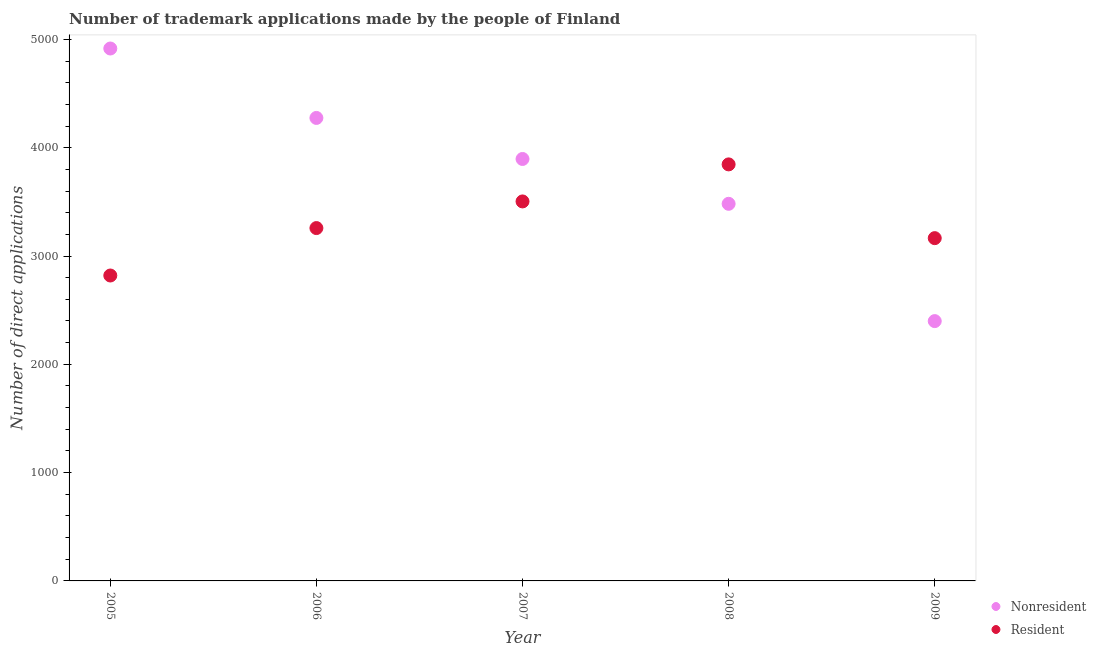Is the number of dotlines equal to the number of legend labels?
Your response must be concise. Yes. What is the number of trademark applications made by residents in 2005?
Ensure brevity in your answer.  2820. Across all years, what is the maximum number of trademark applications made by non residents?
Your answer should be very brief. 4916. Across all years, what is the minimum number of trademark applications made by residents?
Make the answer very short. 2820. What is the total number of trademark applications made by non residents in the graph?
Make the answer very short. 1.90e+04. What is the difference between the number of trademark applications made by non residents in 2005 and that in 2009?
Provide a succinct answer. 2517. What is the difference between the number of trademark applications made by non residents in 2007 and the number of trademark applications made by residents in 2006?
Keep it short and to the point. 638. What is the average number of trademark applications made by residents per year?
Make the answer very short. 3318.6. In the year 2007, what is the difference between the number of trademark applications made by non residents and number of trademark applications made by residents?
Provide a short and direct response. 392. What is the ratio of the number of trademark applications made by residents in 2005 to that in 2006?
Offer a very short reply. 0.87. Is the number of trademark applications made by non residents in 2006 less than that in 2008?
Provide a short and direct response. No. Is the difference between the number of trademark applications made by residents in 2005 and 2006 greater than the difference between the number of trademark applications made by non residents in 2005 and 2006?
Give a very brief answer. No. What is the difference between the highest and the second highest number of trademark applications made by non residents?
Your response must be concise. 641. What is the difference between the highest and the lowest number of trademark applications made by non residents?
Provide a succinct answer. 2517. In how many years, is the number of trademark applications made by residents greater than the average number of trademark applications made by residents taken over all years?
Your answer should be compact. 2. Is the sum of the number of trademark applications made by non residents in 2008 and 2009 greater than the maximum number of trademark applications made by residents across all years?
Your answer should be compact. Yes. Does the number of trademark applications made by residents monotonically increase over the years?
Provide a short and direct response. No. Is the number of trademark applications made by residents strictly greater than the number of trademark applications made by non residents over the years?
Offer a very short reply. No. How many years are there in the graph?
Your answer should be very brief. 5. Are the values on the major ticks of Y-axis written in scientific E-notation?
Your response must be concise. No. Does the graph contain grids?
Ensure brevity in your answer.  No. Where does the legend appear in the graph?
Make the answer very short. Bottom right. How many legend labels are there?
Keep it short and to the point. 2. What is the title of the graph?
Your response must be concise. Number of trademark applications made by the people of Finland. Does "Urban" appear as one of the legend labels in the graph?
Your response must be concise. No. What is the label or title of the Y-axis?
Your answer should be compact. Number of direct applications. What is the Number of direct applications in Nonresident in 2005?
Offer a terse response. 4916. What is the Number of direct applications in Resident in 2005?
Offer a terse response. 2820. What is the Number of direct applications in Nonresident in 2006?
Provide a short and direct response. 4275. What is the Number of direct applications in Resident in 2006?
Give a very brief answer. 3258. What is the Number of direct applications of Nonresident in 2007?
Provide a succinct answer. 3896. What is the Number of direct applications of Resident in 2007?
Make the answer very short. 3504. What is the Number of direct applications in Nonresident in 2008?
Offer a terse response. 3482. What is the Number of direct applications of Resident in 2008?
Ensure brevity in your answer.  3846. What is the Number of direct applications in Nonresident in 2009?
Ensure brevity in your answer.  2399. What is the Number of direct applications of Resident in 2009?
Your answer should be compact. 3165. Across all years, what is the maximum Number of direct applications of Nonresident?
Offer a very short reply. 4916. Across all years, what is the maximum Number of direct applications of Resident?
Ensure brevity in your answer.  3846. Across all years, what is the minimum Number of direct applications of Nonresident?
Ensure brevity in your answer.  2399. Across all years, what is the minimum Number of direct applications in Resident?
Your answer should be compact. 2820. What is the total Number of direct applications of Nonresident in the graph?
Keep it short and to the point. 1.90e+04. What is the total Number of direct applications of Resident in the graph?
Your answer should be compact. 1.66e+04. What is the difference between the Number of direct applications in Nonresident in 2005 and that in 2006?
Provide a succinct answer. 641. What is the difference between the Number of direct applications in Resident in 2005 and that in 2006?
Your answer should be very brief. -438. What is the difference between the Number of direct applications of Nonresident in 2005 and that in 2007?
Provide a succinct answer. 1020. What is the difference between the Number of direct applications in Resident in 2005 and that in 2007?
Your answer should be compact. -684. What is the difference between the Number of direct applications of Nonresident in 2005 and that in 2008?
Your answer should be very brief. 1434. What is the difference between the Number of direct applications of Resident in 2005 and that in 2008?
Provide a succinct answer. -1026. What is the difference between the Number of direct applications in Nonresident in 2005 and that in 2009?
Your response must be concise. 2517. What is the difference between the Number of direct applications of Resident in 2005 and that in 2009?
Keep it short and to the point. -345. What is the difference between the Number of direct applications of Nonresident in 2006 and that in 2007?
Your answer should be very brief. 379. What is the difference between the Number of direct applications in Resident in 2006 and that in 2007?
Offer a very short reply. -246. What is the difference between the Number of direct applications in Nonresident in 2006 and that in 2008?
Keep it short and to the point. 793. What is the difference between the Number of direct applications of Resident in 2006 and that in 2008?
Provide a succinct answer. -588. What is the difference between the Number of direct applications of Nonresident in 2006 and that in 2009?
Keep it short and to the point. 1876. What is the difference between the Number of direct applications of Resident in 2006 and that in 2009?
Keep it short and to the point. 93. What is the difference between the Number of direct applications in Nonresident in 2007 and that in 2008?
Offer a very short reply. 414. What is the difference between the Number of direct applications in Resident in 2007 and that in 2008?
Your response must be concise. -342. What is the difference between the Number of direct applications of Nonresident in 2007 and that in 2009?
Provide a short and direct response. 1497. What is the difference between the Number of direct applications of Resident in 2007 and that in 2009?
Your response must be concise. 339. What is the difference between the Number of direct applications in Nonresident in 2008 and that in 2009?
Your answer should be very brief. 1083. What is the difference between the Number of direct applications in Resident in 2008 and that in 2009?
Offer a very short reply. 681. What is the difference between the Number of direct applications of Nonresident in 2005 and the Number of direct applications of Resident in 2006?
Your answer should be compact. 1658. What is the difference between the Number of direct applications in Nonresident in 2005 and the Number of direct applications in Resident in 2007?
Your response must be concise. 1412. What is the difference between the Number of direct applications of Nonresident in 2005 and the Number of direct applications of Resident in 2008?
Keep it short and to the point. 1070. What is the difference between the Number of direct applications of Nonresident in 2005 and the Number of direct applications of Resident in 2009?
Give a very brief answer. 1751. What is the difference between the Number of direct applications of Nonresident in 2006 and the Number of direct applications of Resident in 2007?
Keep it short and to the point. 771. What is the difference between the Number of direct applications of Nonresident in 2006 and the Number of direct applications of Resident in 2008?
Ensure brevity in your answer.  429. What is the difference between the Number of direct applications in Nonresident in 2006 and the Number of direct applications in Resident in 2009?
Offer a very short reply. 1110. What is the difference between the Number of direct applications of Nonresident in 2007 and the Number of direct applications of Resident in 2009?
Give a very brief answer. 731. What is the difference between the Number of direct applications of Nonresident in 2008 and the Number of direct applications of Resident in 2009?
Your answer should be very brief. 317. What is the average Number of direct applications of Nonresident per year?
Offer a very short reply. 3793.6. What is the average Number of direct applications in Resident per year?
Provide a short and direct response. 3318.6. In the year 2005, what is the difference between the Number of direct applications in Nonresident and Number of direct applications in Resident?
Offer a terse response. 2096. In the year 2006, what is the difference between the Number of direct applications in Nonresident and Number of direct applications in Resident?
Keep it short and to the point. 1017. In the year 2007, what is the difference between the Number of direct applications of Nonresident and Number of direct applications of Resident?
Your response must be concise. 392. In the year 2008, what is the difference between the Number of direct applications of Nonresident and Number of direct applications of Resident?
Ensure brevity in your answer.  -364. In the year 2009, what is the difference between the Number of direct applications of Nonresident and Number of direct applications of Resident?
Provide a short and direct response. -766. What is the ratio of the Number of direct applications in Nonresident in 2005 to that in 2006?
Your answer should be very brief. 1.15. What is the ratio of the Number of direct applications in Resident in 2005 to that in 2006?
Provide a short and direct response. 0.87. What is the ratio of the Number of direct applications in Nonresident in 2005 to that in 2007?
Keep it short and to the point. 1.26. What is the ratio of the Number of direct applications in Resident in 2005 to that in 2007?
Offer a very short reply. 0.8. What is the ratio of the Number of direct applications in Nonresident in 2005 to that in 2008?
Provide a short and direct response. 1.41. What is the ratio of the Number of direct applications in Resident in 2005 to that in 2008?
Give a very brief answer. 0.73. What is the ratio of the Number of direct applications in Nonresident in 2005 to that in 2009?
Your answer should be compact. 2.05. What is the ratio of the Number of direct applications in Resident in 2005 to that in 2009?
Keep it short and to the point. 0.89. What is the ratio of the Number of direct applications in Nonresident in 2006 to that in 2007?
Your answer should be compact. 1.1. What is the ratio of the Number of direct applications in Resident in 2006 to that in 2007?
Your answer should be compact. 0.93. What is the ratio of the Number of direct applications in Nonresident in 2006 to that in 2008?
Make the answer very short. 1.23. What is the ratio of the Number of direct applications of Resident in 2006 to that in 2008?
Your answer should be compact. 0.85. What is the ratio of the Number of direct applications of Nonresident in 2006 to that in 2009?
Your answer should be compact. 1.78. What is the ratio of the Number of direct applications of Resident in 2006 to that in 2009?
Offer a terse response. 1.03. What is the ratio of the Number of direct applications of Nonresident in 2007 to that in 2008?
Provide a succinct answer. 1.12. What is the ratio of the Number of direct applications of Resident in 2007 to that in 2008?
Your answer should be very brief. 0.91. What is the ratio of the Number of direct applications in Nonresident in 2007 to that in 2009?
Ensure brevity in your answer.  1.62. What is the ratio of the Number of direct applications of Resident in 2007 to that in 2009?
Offer a very short reply. 1.11. What is the ratio of the Number of direct applications of Nonresident in 2008 to that in 2009?
Provide a short and direct response. 1.45. What is the ratio of the Number of direct applications in Resident in 2008 to that in 2009?
Keep it short and to the point. 1.22. What is the difference between the highest and the second highest Number of direct applications of Nonresident?
Your answer should be compact. 641. What is the difference between the highest and the second highest Number of direct applications in Resident?
Ensure brevity in your answer.  342. What is the difference between the highest and the lowest Number of direct applications of Nonresident?
Provide a succinct answer. 2517. What is the difference between the highest and the lowest Number of direct applications in Resident?
Keep it short and to the point. 1026. 